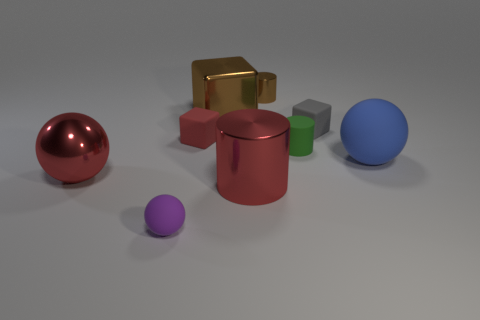Add 1 brown metallic cylinders. How many objects exist? 10 Subtract all cylinders. How many objects are left? 6 Subtract 0 brown balls. How many objects are left? 9 Subtract all tiny purple things. Subtract all tiny gray rubber objects. How many objects are left? 7 Add 4 tiny metal things. How many tiny metal things are left? 5 Add 3 tiny purple rubber balls. How many tiny purple rubber balls exist? 4 